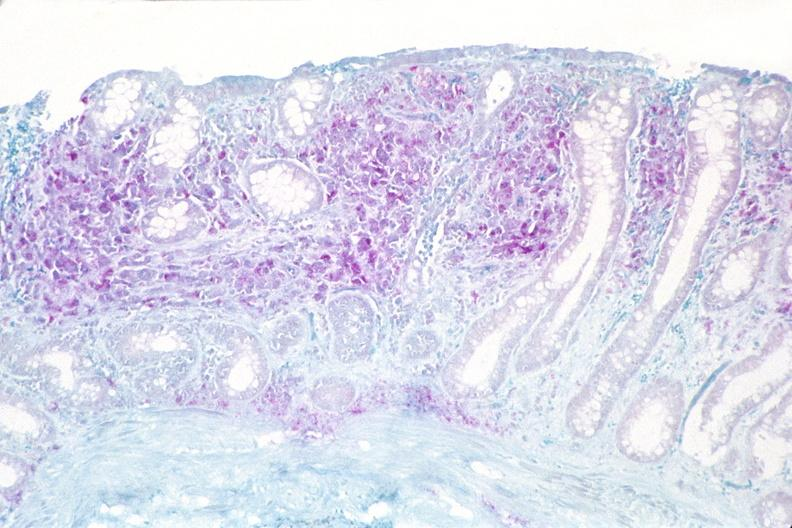s gastrointestinal present?
Answer the question using a single word or phrase. Yes 